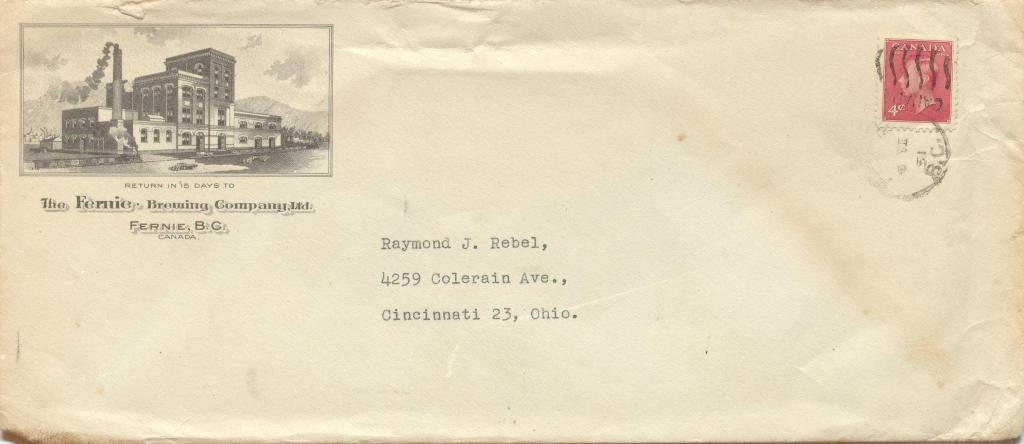<image>
Create a compact narrative representing the image presented. a postal envelope that says to return in 15 days 